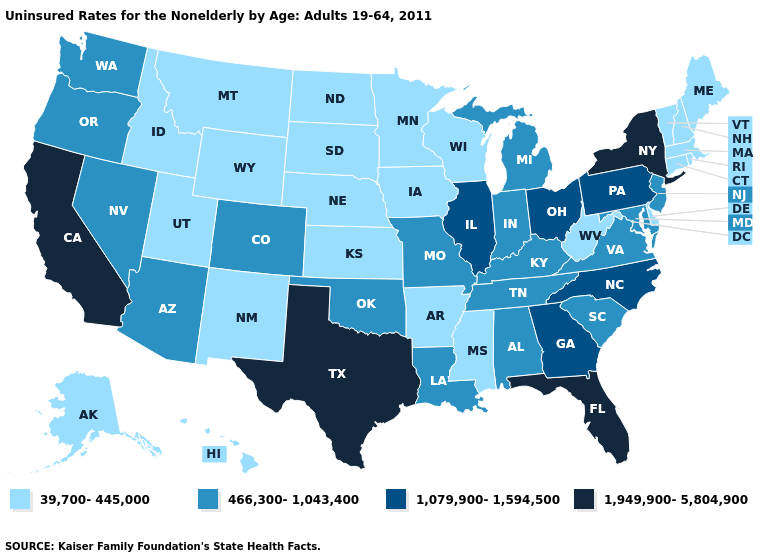Which states have the lowest value in the West?
Keep it brief. Alaska, Hawaii, Idaho, Montana, New Mexico, Utah, Wyoming. Name the states that have a value in the range 1,949,900-5,804,900?
Give a very brief answer. California, Florida, New York, Texas. What is the value of Iowa?
Concise answer only. 39,700-445,000. Which states have the highest value in the USA?
Keep it brief. California, Florida, New York, Texas. How many symbols are there in the legend?
Short answer required. 4. Which states have the lowest value in the Northeast?
Answer briefly. Connecticut, Maine, Massachusetts, New Hampshire, Rhode Island, Vermont. Name the states that have a value in the range 466,300-1,043,400?
Give a very brief answer. Alabama, Arizona, Colorado, Indiana, Kentucky, Louisiana, Maryland, Michigan, Missouri, Nevada, New Jersey, Oklahoma, Oregon, South Carolina, Tennessee, Virginia, Washington. Which states hav the highest value in the MidWest?
Give a very brief answer. Illinois, Ohio. What is the value of Rhode Island?
Be succinct. 39,700-445,000. What is the highest value in the Northeast ?
Keep it brief. 1,949,900-5,804,900. What is the value of California?
Write a very short answer. 1,949,900-5,804,900. Name the states that have a value in the range 466,300-1,043,400?
Give a very brief answer. Alabama, Arizona, Colorado, Indiana, Kentucky, Louisiana, Maryland, Michigan, Missouri, Nevada, New Jersey, Oklahoma, Oregon, South Carolina, Tennessee, Virginia, Washington. What is the highest value in states that border South Dakota?
Quick response, please. 39,700-445,000. Name the states that have a value in the range 39,700-445,000?
Keep it brief. Alaska, Arkansas, Connecticut, Delaware, Hawaii, Idaho, Iowa, Kansas, Maine, Massachusetts, Minnesota, Mississippi, Montana, Nebraska, New Hampshire, New Mexico, North Dakota, Rhode Island, South Dakota, Utah, Vermont, West Virginia, Wisconsin, Wyoming. Does the first symbol in the legend represent the smallest category?
Short answer required. Yes. 